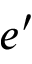<formula> <loc_0><loc_0><loc_500><loc_500>e ^ { \prime }</formula> 